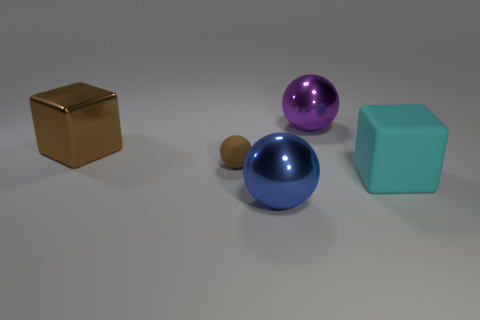Suppose these objects were part of a children's game, what kind of game could it be? If these objects were part of a children's game, they could be used in a variety of educational and playful activities. For example, they might be used in a matching game where children pair objects with corresponding shapes or colors. Another possibility is a sorting game, where the goal is to arrange the objects by size, shape, or color. Additionally, these objects could serve as game pieces in a board game, where each shape represents a different character or role. 